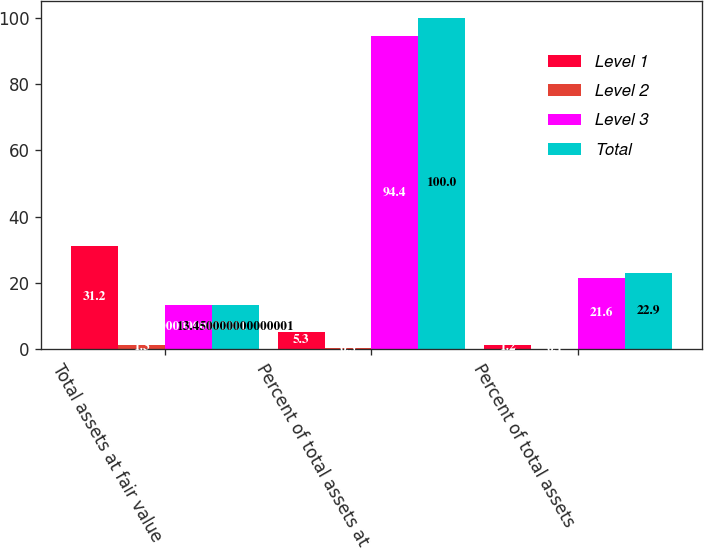Convert chart to OTSL. <chart><loc_0><loc_0><loc_500><loc_500><stacked_bar_chart><ecel><fcel>Total assets at fair value<fcel>Percent of total assets at<fcel>Percent of total assets<nl><fcel>Level 1<fcel>31.2<fcel>5.3<fcel>1.2<nl><fcel>Level 2<fcel>1.3<fcel>0.3<fcel>0.1<nl><fcel>Level 3<fcel>13.45<fcel>94.4<fcel>21.6<nl><fcel>Total<fcel>13.45<fcel>100<fcel>22.9<nl></chart> 